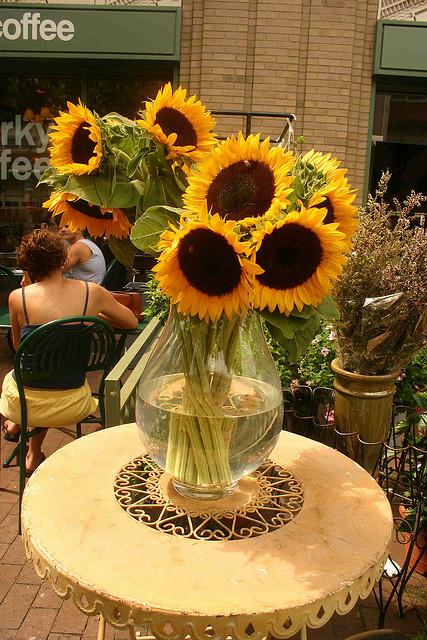Is the table ornate?
Write a very short answer. Yes. What types of flowers are these?
Quick response, please. Sunflowers. Why are the flowers on the table?
Concise answer only. Decoration. 